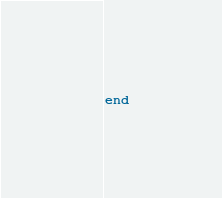<code> <loc_0><loc_0><loc_500><loc_500><_Ruby_>end
</code> 